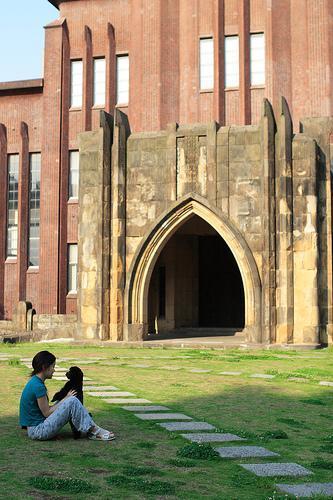How many puppies?
Give a very brief answer. 1. 